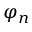<formula> <loc_0><loc_0><loc_500><loc_500>\varphi _ { n }</formula> 